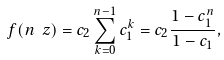<formula> <loc_0><loc_0><loc_500><loc_500>f ( n \ z ) = c _ { 2 } \sum _ { k = 0 } ^ { n - 1 } c _ { 1 } ^ { k } = c _ { 2 } \frac { 1 - c _ { 1 } ^ { n } } { 1 - c _ { 1 } } ,</formula> 